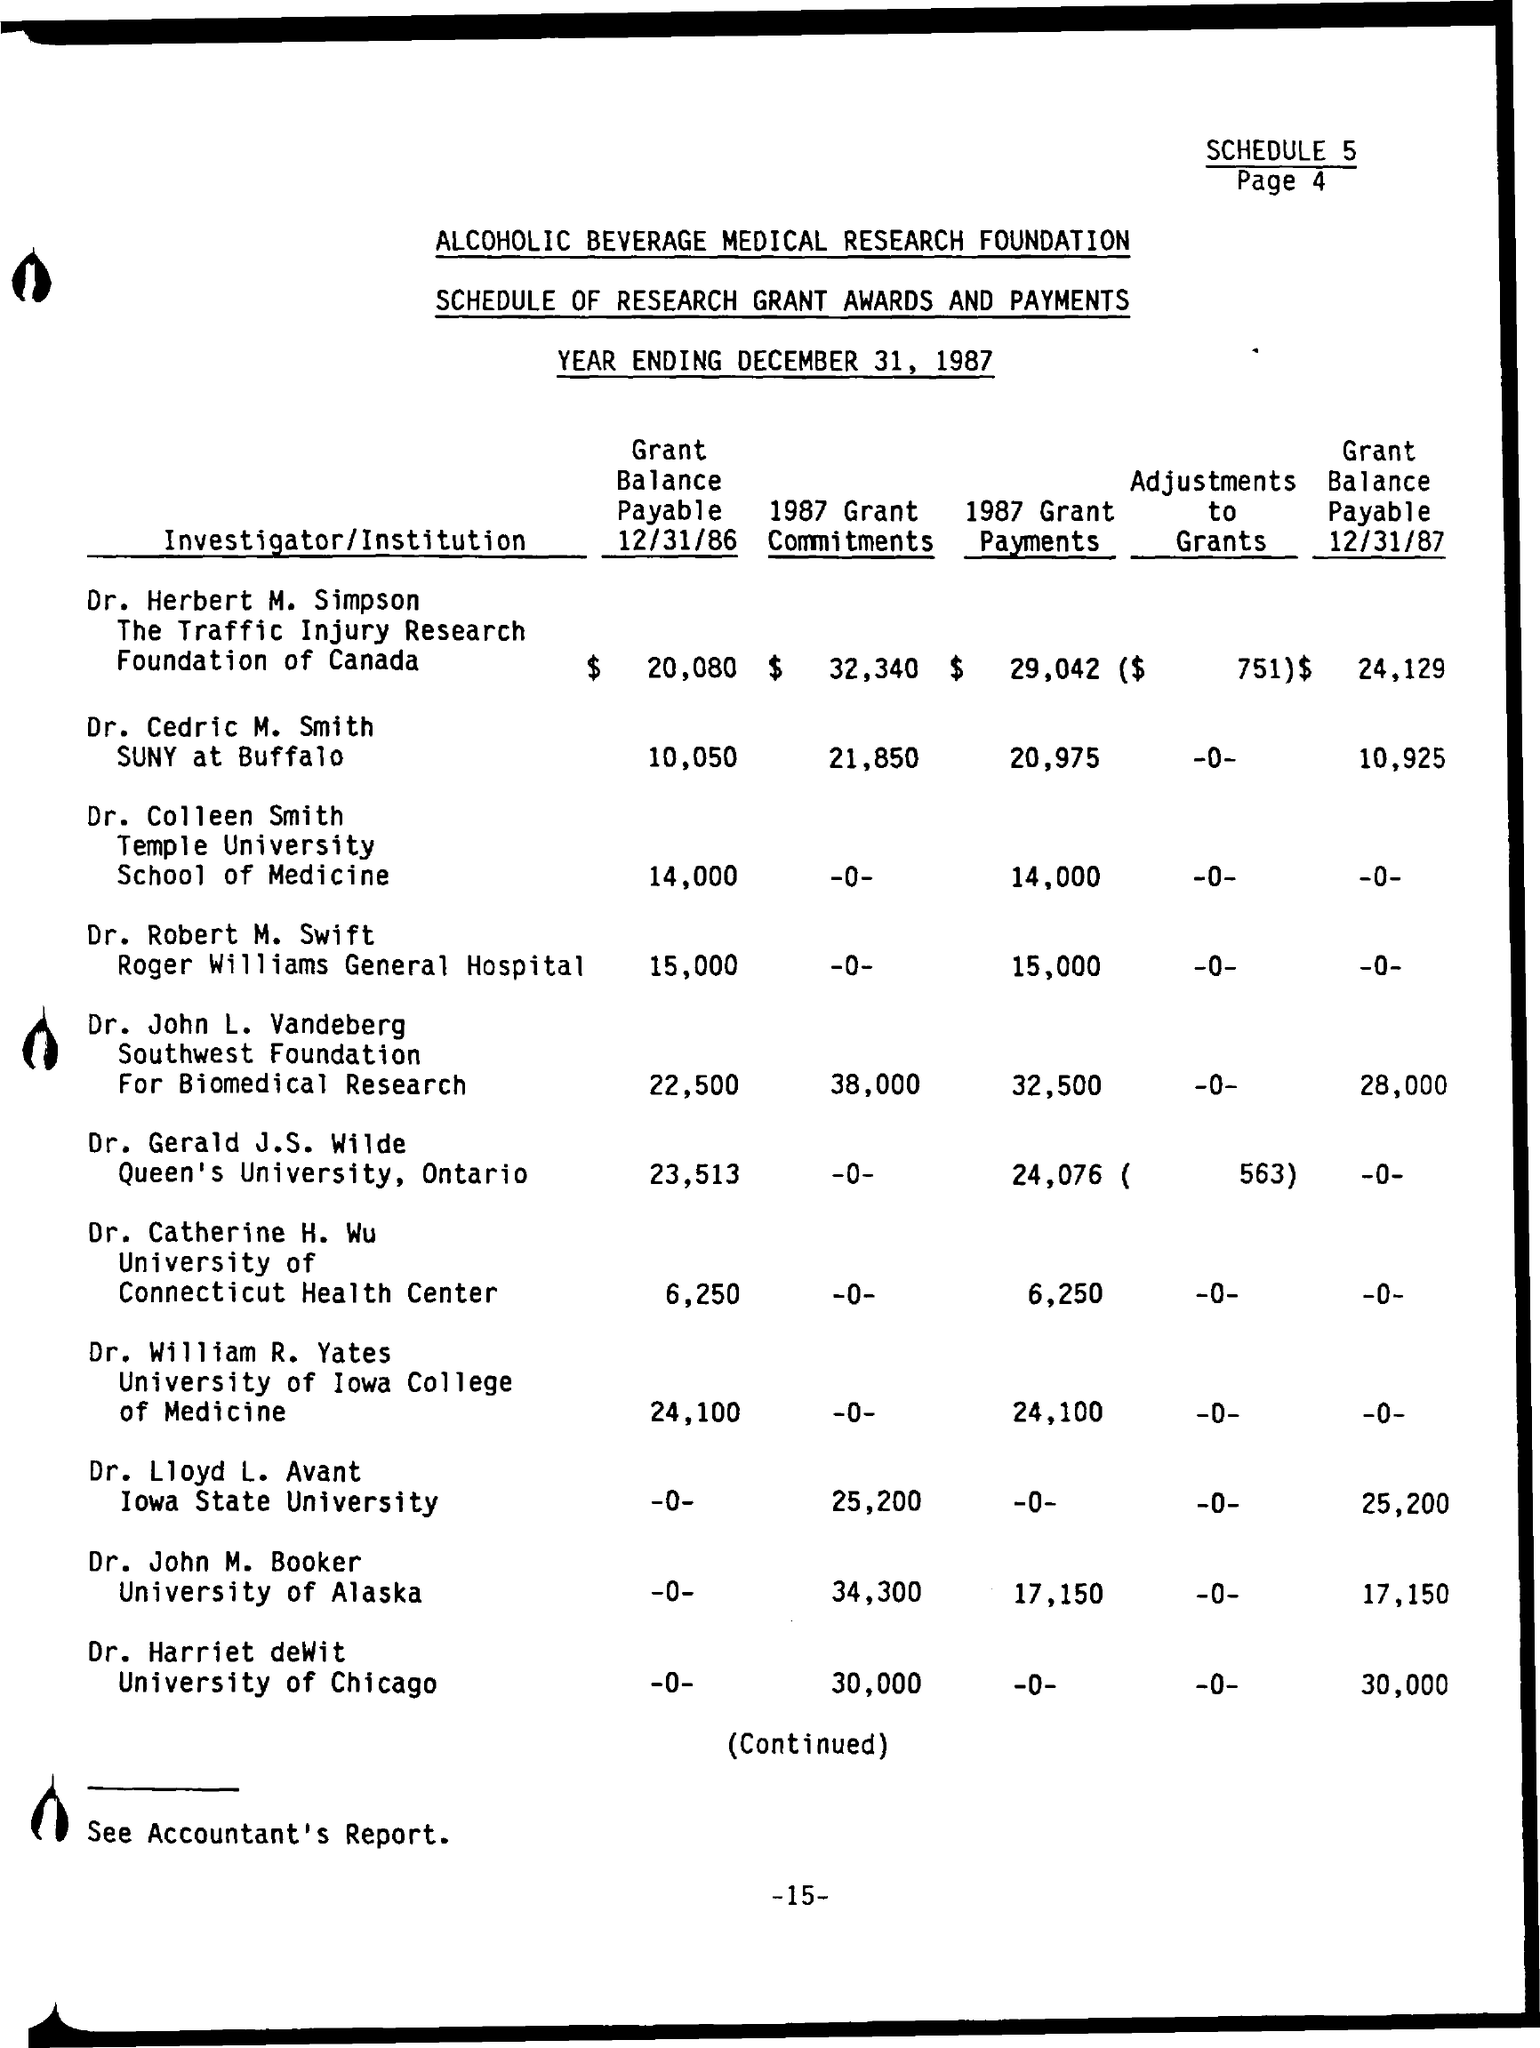Highlight a few significant elements in this photo. The Grant Balance Payable as of 12/31/86, paid by Dr. Cedric M. Smith, was $10,050. The grant balance payable as of December 31, 1986, was $20,080, paid by Dr. Herbert M. Simpson. The Grant Balance Payable as of December 31, 1987, was $24,129, paid by Dr. Herbert M. Simpson. On December 31, 1986, Dr. John L. Vanderberg made a grant balance payable of $22,500. The grant balance payable as of December 31, 1987, by Dr. Cedric M. Smith is $10,925. 